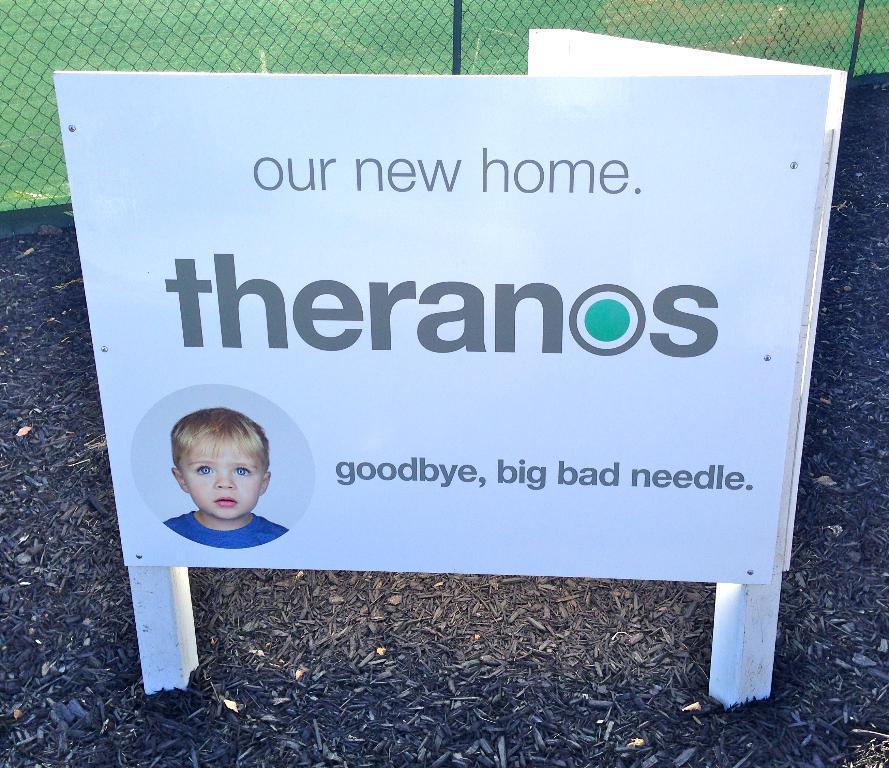Please provide a concise description of this image. In this picture we can see a white board on the path. We can see a person on this board. There is some fencing in the background. Some grass is visible on the ground. 